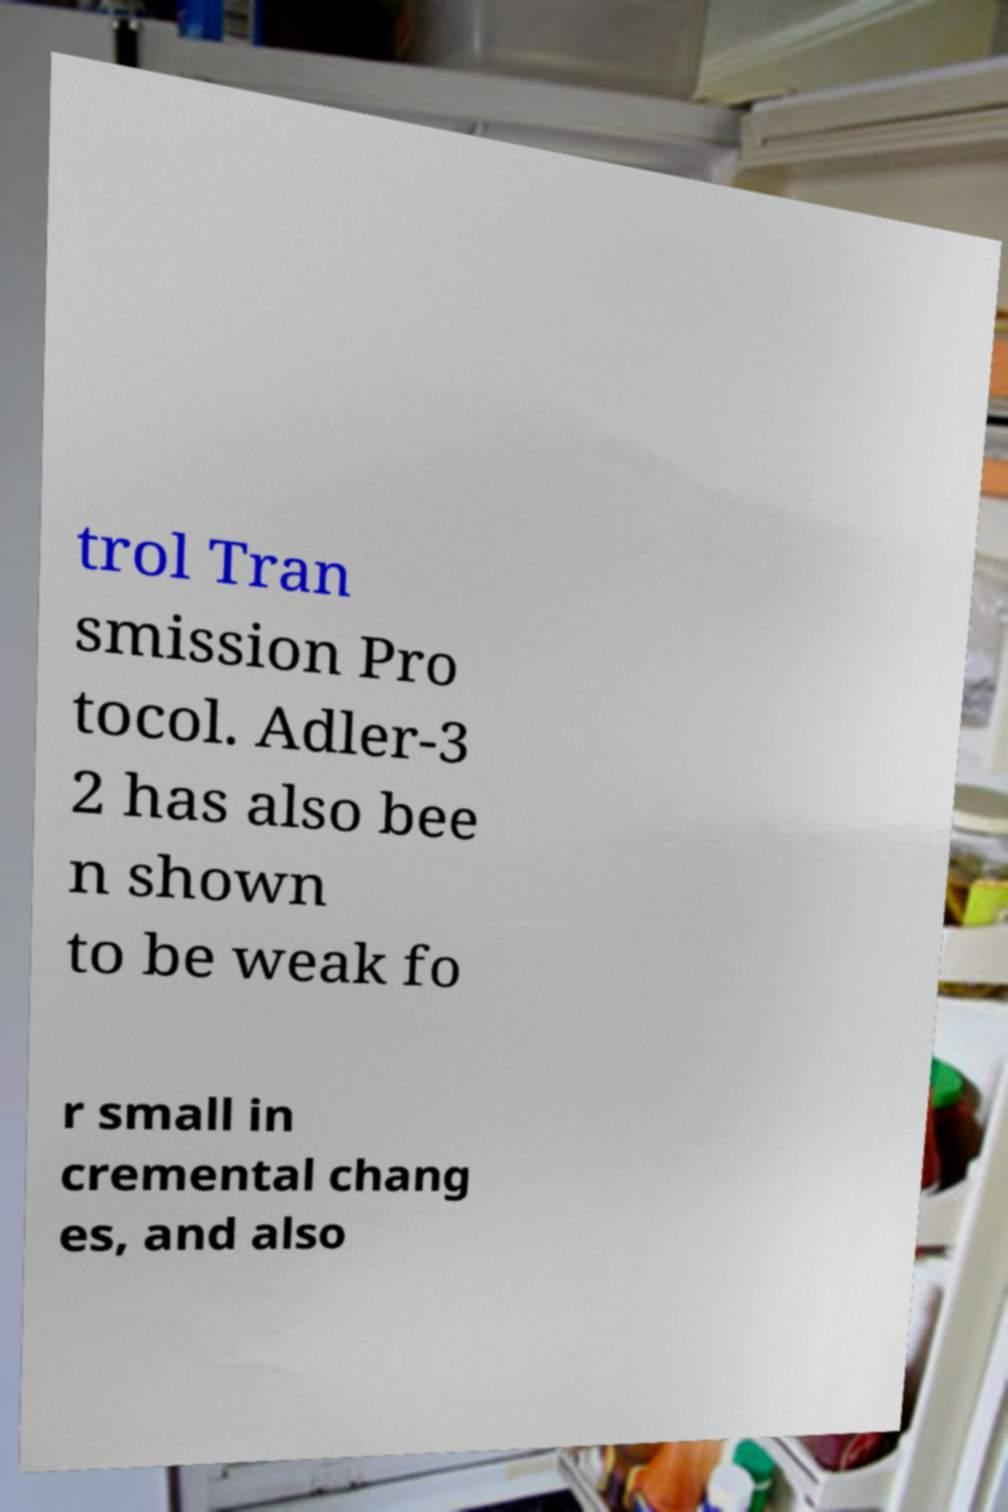Can you read and provide the text displayed in the image?This photo seems to have some interesting text. Can you extract and type it out for me? trol Tran smission Pro tocol. Adler-3 2 has also bee n shown to be weak fo r small in cremental chang es, and also 